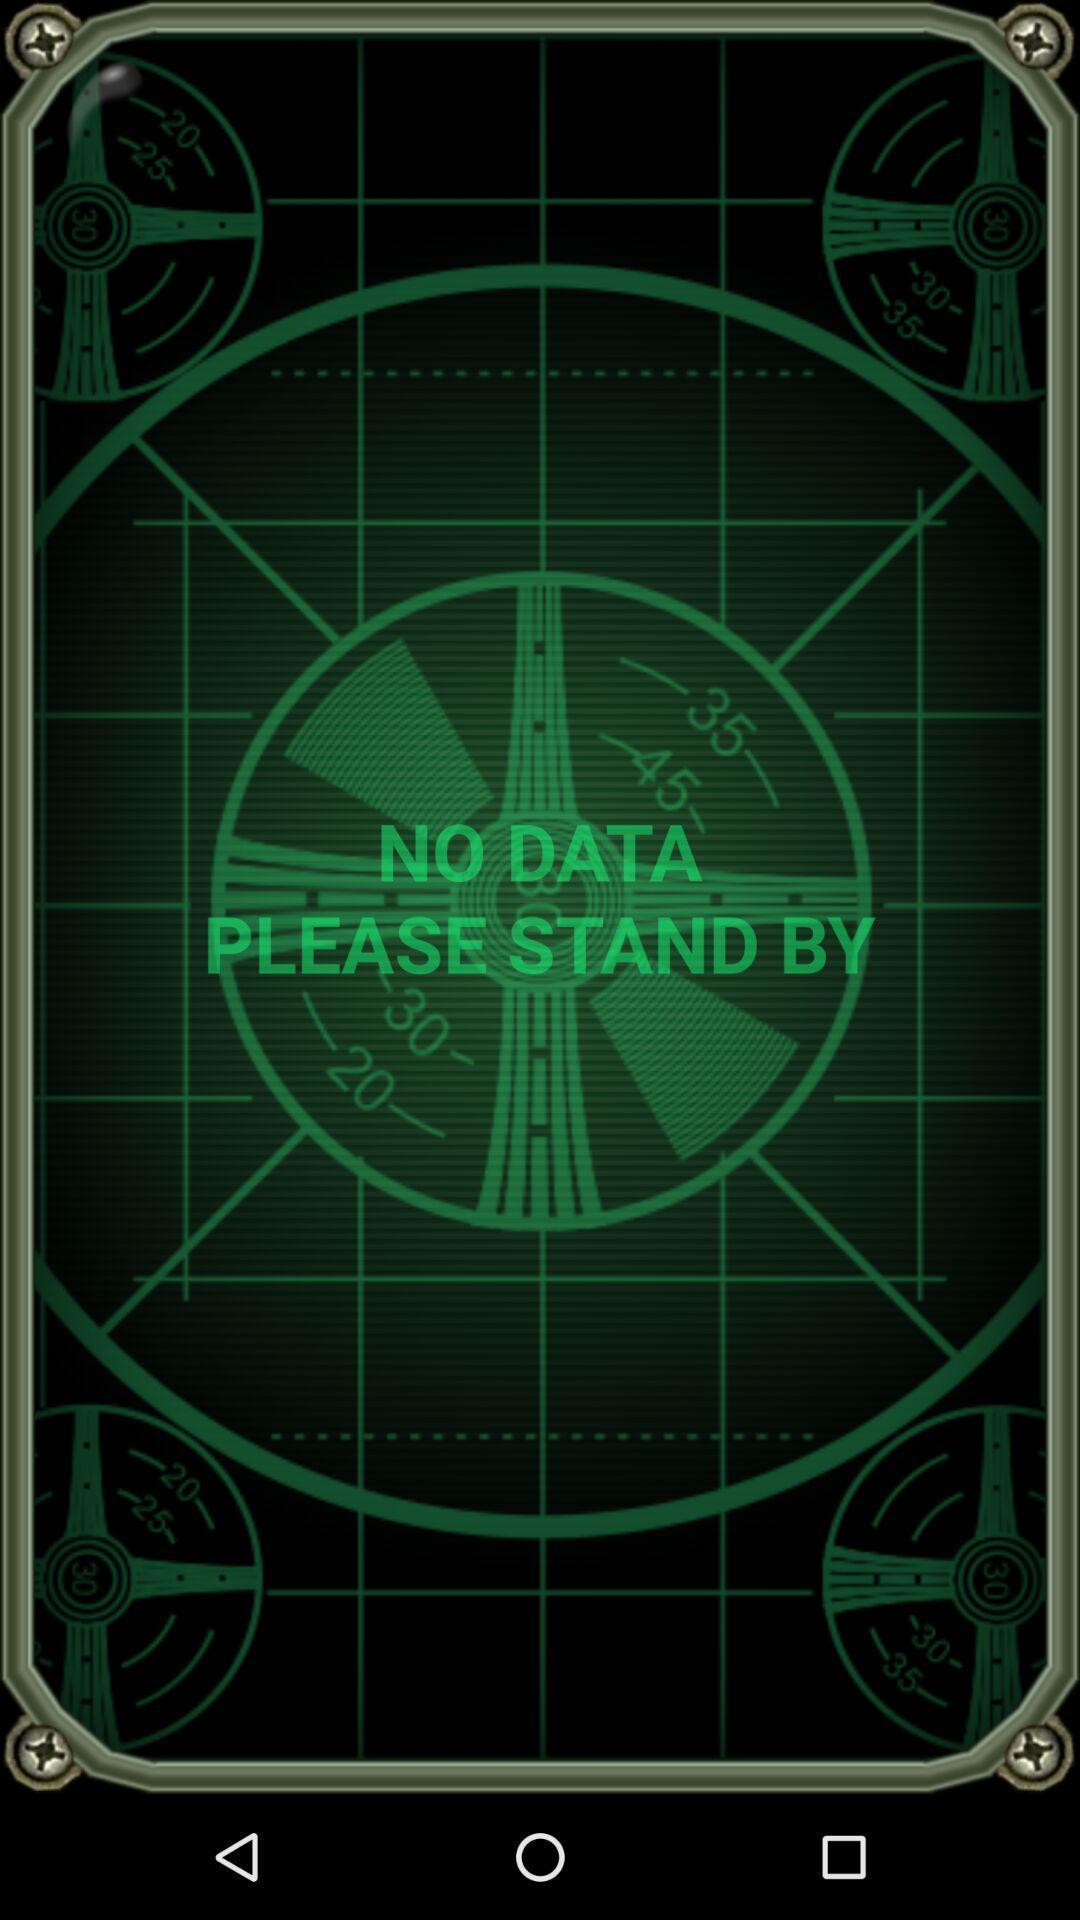Summarize the main components in this picture. Window displaying about weather information app. 